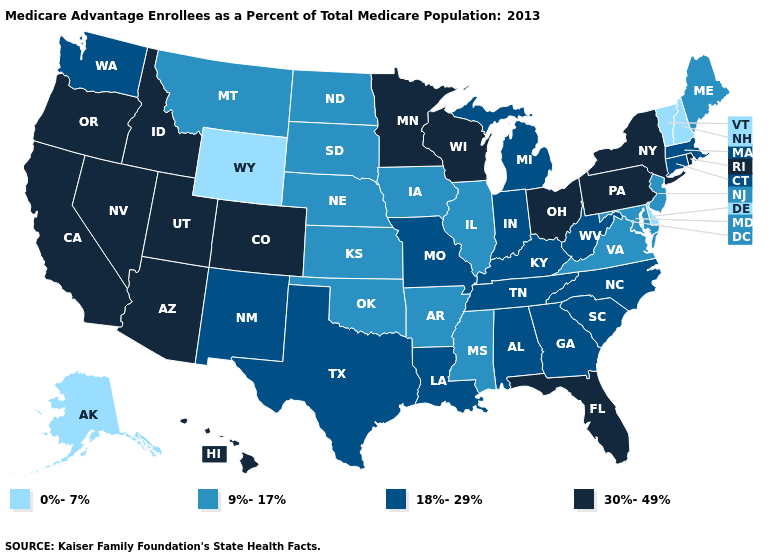Among the states that border Arkansas , does Mississippi have the highest value?
Concise answer only. No. Among the states that border Massachusetts , which have the lowest value?
Quick response, please. New Hampshire, Vermont. Name the states that have a value in the range 30%-49%?
Give a very brief answer. Arizona, California, Colorado, Florida, Hawaii, Idaho, Minnesota, Nevada, New York, Ohio, Oregon, Pennsylvania, Rhode Island, Utah, Wisconsin. Name the states that have a value in the range 0%-7%?
Keep it brief. Alaska, Delaware, New Hampshire, Vermont, Wyoming. Name the states that have a value in the range 30%-49%?
Give a very brief answer. Arizona, California, Colorado, Florida, Hawaii, Idaho, Minnesota, Nevada, New York, Ohio, Oregon, Pennsylvania, Rhode Island, Utah, Wisconsin. Does the map have missing data?
Give a very brief answer. No. Does Nevada have the same value as Oregon?
Short answer required. Yes. What is the lowest value in the West?
Give a very brief answer. 0%-7%. Name the states that have a value in the range 9%-17%?
Quick response, please. Arkansas, Iowa, Illinois, Kansas, Maryland, Maine, Mississippi, Montana, North Dakota, Nebraska, New Jersey, Oklahoma, South Dakota, Virginia. Does the map have missing data?
Be succinct. No. Does Missouri have a higher value than New Jersey?
Short answer required. Yes. Name the states that have a value in the range 9%-17%?
Concise answer only. Arkansas, Iowa, Illinois, Kansas, Maryland, Maine, Mississippi, Montana, North Dakota, Nebraska, New Jersey, Oklahoma, South Dakota, Virginia. Does Wyoming have the lowest value in the USA?
Write a very short answer. Yes. Among the states that border Delaware , does New Jersey have the lowest value?
Give a very brief answer. Yes. Name the states that have a value in the range 0%-7%?
Quick response, please. Alaska, Delaware, New Hampshire, Vermont, Wyoming. 